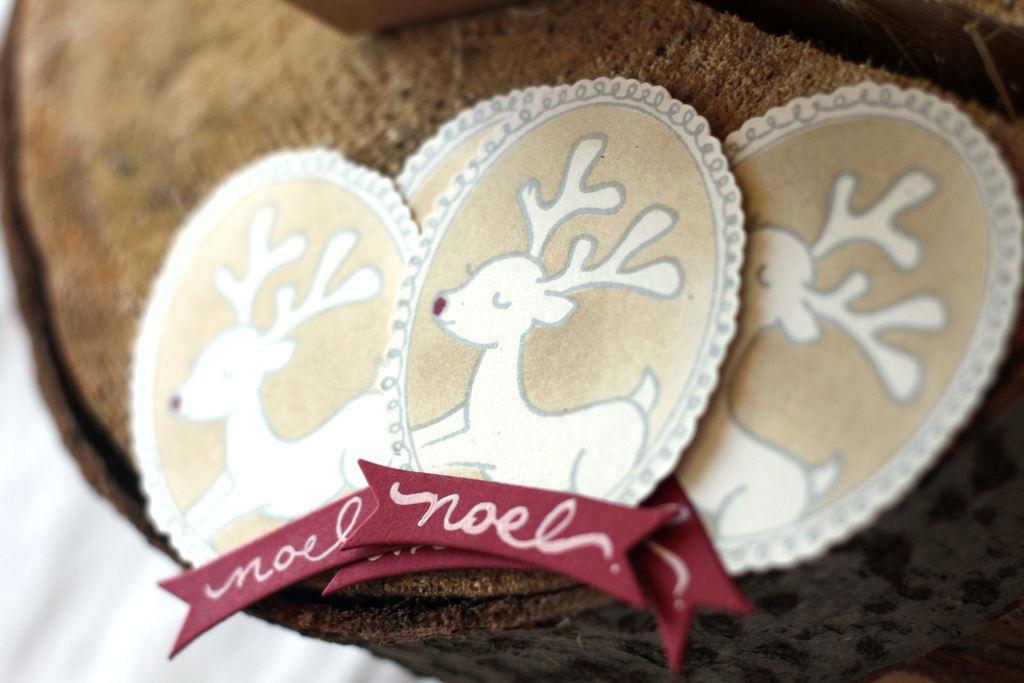Could you give a brief overview of what you see in this image? In this image we can see small cards with animal pictures on them on the wooden piece. On the left side at the bottom the image is blur. 